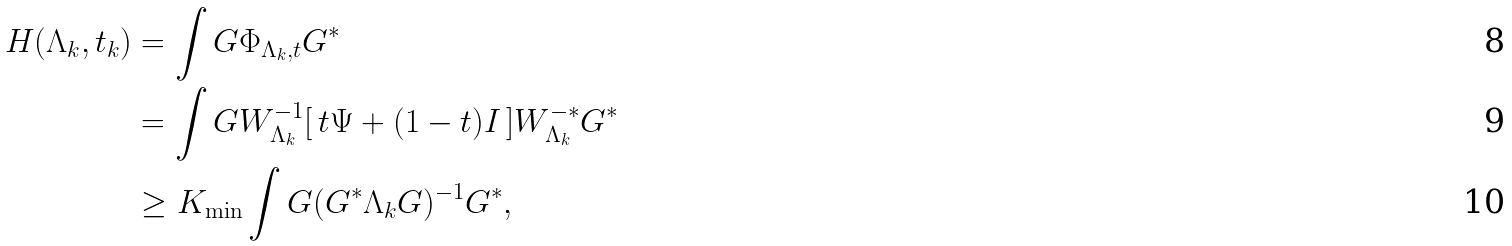Convert formula to latex. <formula><loc_0><loc_0><loc_500><loc_500>H ( \Lambda _ { k } , t _ { k } ) & = \int G \Phi _ { \Lambda _ { k } , t } G ^ { * } \\ & = \int G W _ { \Lambda _ { k } } ^ { - 1 } [ \, t \Psi + ( 1 - t ) I \, ] W _ { \Lambda _ { k } } ^ { - * } G ^ { * } \\ & \geq K _ { \min } \int G ( G ^ { * } \Lambda _ { k } G ) ^ { - 1 } G ^ { * } ,</formula> 